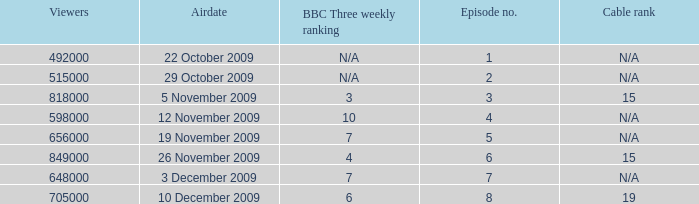Could you parse the entire table? {'header': ['Viewers', 'Airdate', 'BBC Three weekly ranking', 'Episode no.', 'Cable rank'], 'rows': [['492000', '22 October 2009', 'N/A', '1', 'N/A'], ['515000', '29 October 2009', 'N/A', '2', 'N/A'], ['818000', '5 November 2009', '3', '3', '15'], ['598000', '12 November 2009', '10', '4', 'N/A'], ['656000', '19 November 2009', '7', '5', 'N/A'], ['849000', '26 November 2009', '4', '6', '15'], ['648000', '3 December 2009', '7', '7', 'N/A'], ['705000', '10 December 2009', '6', '8', '19']]} What is the  cable rank for episode no. 4? N/A. 